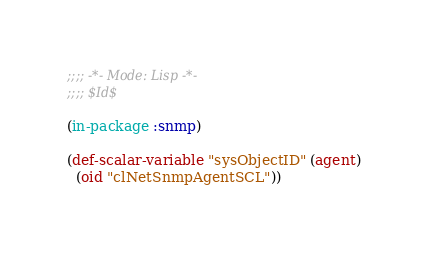Convert code to text. <code><loc_0><loc_0><loc_500><loc_500><_Lisp_>;;;; -*- Mode: Lisp -*-
;;;; $Id$

(in-package :snmp)

(def-scalar-variable "sysObjectID" (agent)
  (oid "clNetSnmpAgentSCL"))
</code> 